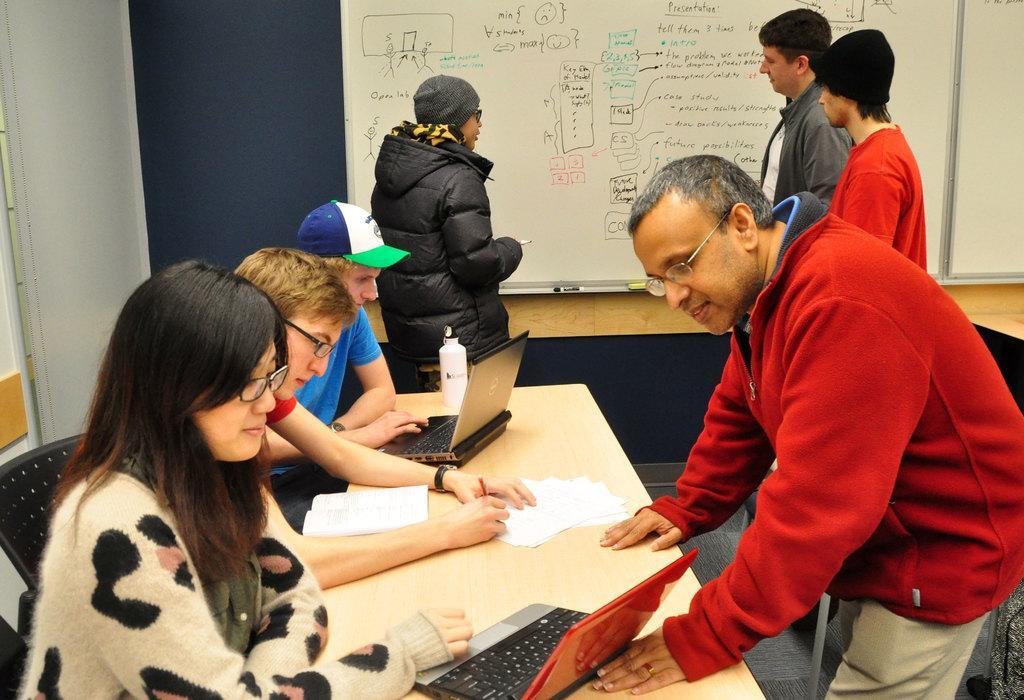Describe this image in one or two sentences. In the picture we can see a table and near to it we can see two men and one woman sitting on the chairs and one man is working in the laptop and he is with a cap and beside him we can see another man sitting and looking in the papers and beside him we can see a woman watching in the laptop and in front of her we can also see a man standing and looking in the laptop and in the background we can see a wall with white color board with some information on it and near it we can see few people standing. 